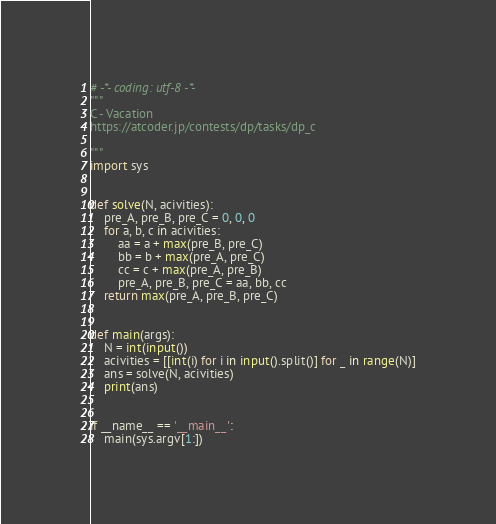Convert code to text. <code><loc_0><loc_0><loc_500><loc_500><_Python_># -*- coding: utf-8 -*-
"""
C - Vacation
https://atcoder.jp/contests/dp/tasks/dp_c

"""
import sys


def solve(N, acivities):
    pre_A, pre_B, pre_C = 0, 0, 0
    for a, b, c in acivities:
        aa = a + max(pre_B, pre_C)
        bb = b + max(pre_A, pre_C)
        cc = c + max(pre_A, pre_B)
        pre_A, pre_B, pre_C = aa, bb, cc
    return max(pre_A, pre_B, pre_C)


def main(args):
    N = int(input())
    acivities = [[int(i) for i in input().split()] for _ in range(N)]
    ans = solve(N, acivities)
    print(ans)


if __name__ == '__main__':
    main(sys.argv[1:])</code> 